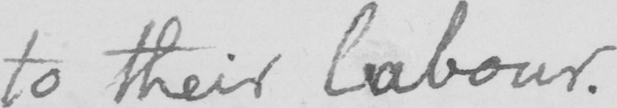What is written in this line of handwriting? to their labour . 